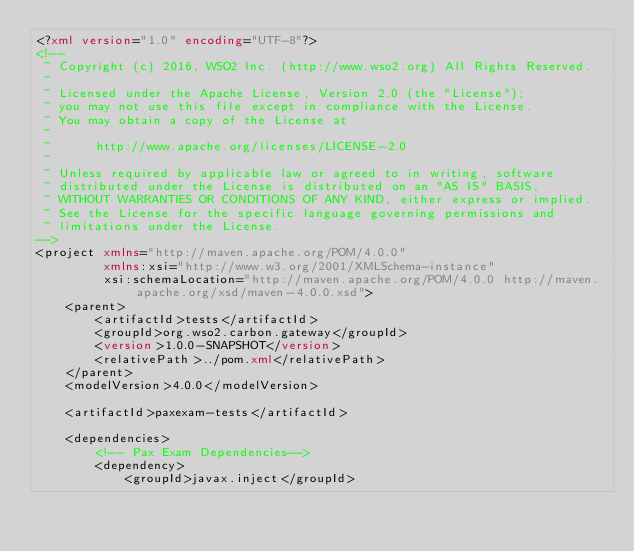Convert code to text. <code><loc_0><loc_0><loc_500><loc_500><_XML_><?xml version="1.0" encoding="UTF-8"?>
<!--
 ~ Copyright (c) 2016, WSO2 Inc. (http://www.wso2.org) All Rights Reserved.
 ~
 ~ Licensed under the Apache License, Version 2.0 (the "License");
 ~ you may not use this file except in compliance with the License.
 ~ You may obtain a copy of the License at
 ~
 ~      http://www.apache.org/licenses/LICENSE-2.0
 ~
 ~ Unless required by applicable law or agreed to in writing, software
 ~ distributed under the License is distributed on an "AS IS" BASIS,
 ~ WITHOUT WARRANTIES OR CONDITIONS OF ANY KIND, either express or implied.
 ~ See the License for the specific language governing permissions and
 ~ limitations under the License.
-->
<project xmlns="http://maven.apache.org/POM/4.0.0"
         xmlns:xsi="http://www.w3.org/2001/XMLSchema-instance"
         xsi:schemaLocation="http://maven.apache.org/POM/4.0.0 http://maven.apache.org/xsd/maven-4.0.0.xsd">
    <parent>
        <artifactId>tests</artifactId>
        <groupId>org.wso2.carbon.gateway</groupId>
        <version>1.0.0-SNAPSHOT</version>
        <relativePath>../pom.xml</relativePath>
    </parent>
    <modelVersion>4.0.0</modelVersion>

    <artifactId>paxexam-tests</artifactId>

    <dependencies>
        <!-- Pax Exam Dependencies-->
        <dependency>
            <groupId>javax.inject</groupId></code> 